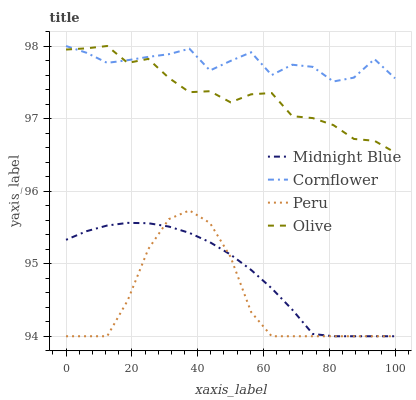Does Peru have the minimum area under the curve?
Answer yes or no. Yes. Does Cornflower have the maximum area under the curve?
Answer yes or no. Yes. Does Midnight Blue have the minimum area under the curve?
Answer yes or no. No. Does Midnight Blue have the maximum area under the curve?
Answer yes or no. No. Is Midnight Blue the smoothest?
Answer yes or no. Yes. Is Cornflower the roughest?
Answer yes or no. Yes. Is Cornflower the smoothest?
Answer yes or no. No. Is Midnight Blue the roughest?
Answer yes or no. No. Does Midnight Blue have the lowest value?
Answer yes or no. Yes. Does Cornflower have the lowest value?
Answer yes or no. No. Does Cornflower have the highest value?
Answer yes or no. Yes. Does Midnight Blue have the highest value?
Answer yes or no. No. Is Peru less than Olive?
Answer yes or no. Yes. Is Cornflower greater than Peru?
Answer yes or no. Yes. Does Peru intersect Midnight Blue?
Answer yes or no. Yes. Is Peru less than Midnight Blue?
Answer yes or no. No. Is Peru greater than Midnight Blue?
Answer yes or no. No. Does Peru intersect Olive?
Answer yes or no. No. 